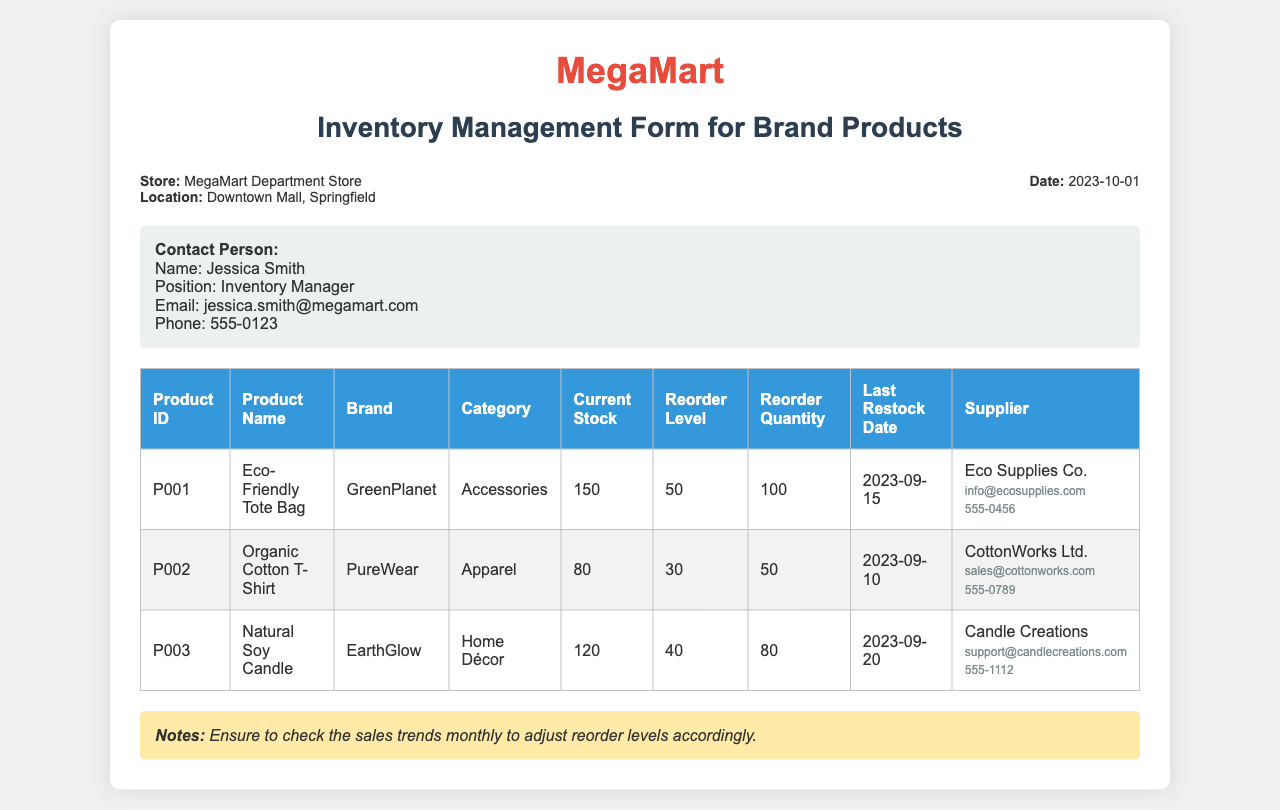What is the store name? The store name is identified at the top of the document, which is MegaMart Department Store.
Answer: MegaMart Department Store What is the location of the store? The location is specified in the header section of the document as Downtown Mall, Springfield.
Answer: Downtown Mall, Springfield Who is the contact person? The contact person is listed under the contact information section.
Answer: Jessica Smith What is the current stock of the Eco-Friendly Tote Bag? The current stock is found in the table under the "Current Stock" column for the Eco-Friendly Tote Bag, which indicates 150 items.
Answer: 150 What is the reorder level for the Organic Cotton T-Shirt? The reorder level can be found in the table under the relevant column for the Organic Cotton T-Shirt, which shows 30.
Answer: 30 How many items should be reordered for the Natural Soy Candle? The reorder quantity is specified in the table for the Natural Soy Candle, which indicates 80.
Answer: 80 When was the last restock date for the Eco-Friendly Tote Bag? The last restock date is documented in the table under the corresponding column, which states 2023-09-15.
Answer: 2023-09-15 What is the email address for the supplier of the Organic Cotton T-Shirt? The supplier's email can be found in the table; for the Organic Cotton T-Shirt, it is sales@cottonworks.com.
Answer: sales@cottonworks.com What is the note regarding sales trends? The note is found at the bottom of the document, stating to ensure to check the sales trends monthly.
Answer: Ensure to check the sales trends monthly 